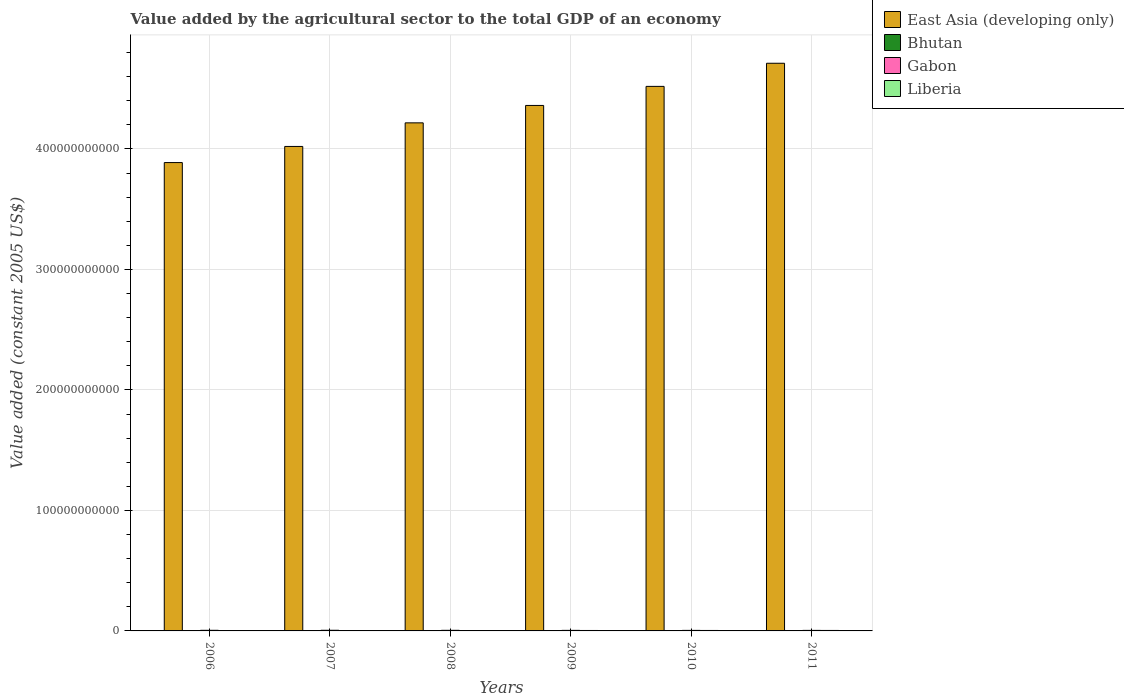Are the number of bars on each tick of the X-axis equal?
Provide a succinct answer. Yes. In how many cases, is the number of bars for a given year not equal to the number of legend labels?
Provide a succinct answer. 0. What is the value added by the agricultural sector in Liberia in 2008?
Make the answer very short. 3.48e+08. Across all years, what is the maximum value added by the agricultural sector in East Asia (developing only)?
Your response must be concise. 4.71e+11. Across all years, what is the minimum value added by the agricultural sector in Bhutan?
Make the answer very short. 1.88e+08. In which year was the value added by the agricultural sector in Liberia maximum?
Provide a short and direct response. 2011. In which year was the value added by the agricultural sector in Liberia minimum?
Your answer should be very brief. 2006. What is the total value added by the agricultural sector in Gabon in the graph?
Give a very brief answer. 2.90e+09. What is the difference between the value added by the agricultural sector in Bhutan in 2006 and that in 2010?
Offer a very short reply. -9.59e+06. What is the difference between the value added by the agricultural sector in Gabon in 2007 and the value added by the agricultural sector in Bhutan in 2006?
Give a very brief answer. 3.48e+08. What is the average value added by the agricultural sector in Gabon per year?
Offer a terse response. 4.83e+08. In the year 2008, what is the difference between the value added by the agricultural sector in Gabon and value added by the agricultural sector in Bhutan?
Give a very brief answer. 3.09e+08. In how many years, is the value added by the agricultural sector in Gabon greater than 120000000000 US$?
Ensure brevity in your answer.  0. What is the ratio of the value added by the agricultural sector in Bhutan in 2009 to that in 2010?
Provide a short and direct response. 0.99. Is the value added by the agricultural sector in Liberia in 2006 less than that in 2007?
Ensure brevity in your answer.  Yes. Is the difference between the value added by the agricultural sector in Gabon in 2007 and 2008 greater than the difference between the value added by the agricultural sector in Bhutan in 2007 and 2008?
Provide a succinct answer. Yes. What is the difference between the highest and the second highest value added by the agricultural sector in Liberia?
Your response must be concise. 1.48e+07. What is the difference between the highest and the lowest value added by the agricultural sector in East Asia (developing only)?
Provide a short and direct response. 8.24e+1. What does the 2nd bar from the left in 2011 represents?
Your response must be concise. Bhutan. What does the 2nd bar from the right in 2011 represents?
Your answer should be compact. Gabon. Is it the case that in every year, the sum of the value added by the agricultural sector in Liberia and value added by the agricultural sector in Bhutan is greater than the value added by the agricultural sector in Gabon?
Your answer should be compact. No. Are all the bars in the graph horizontal?
Provide a succinct answer. No. What is the difference between two consecutive major ticks on the Y-axis?
Offer a terse response. 1.00e+11. Are the values on the major ticks of Y-axis written in scientific E-notation?
Ensure brevity in your answer.  No. Does the graph contain any zero values?
Offer a very short reply. No. Does the graph contain grids?
Provide a short and direct response. Yes. How are the legend labels stacked?
Provide a short and direct response. Vertical. What is the title of the graph?
Keep it short and to the point. Value added by the agricultural sector to the total GDP of an economy. What is the label or title of the X-axis?
Make the answer very short. Years. What is the label or title of the Y-axis?
Give a very brief answer. Value added (constant 2005 US$). What is the Value added (constant 2005 US$) of East Asia (developing only) in 2006?
Keep it short and to the point. 3.89e+11. What is the Value added (constant 2005 US$) of Bhutan in 2006?
Your answer should be compact. 1.88e+08. What is the Value added (constant 2005 US$) of Gabon in 2006?
Offer a very short reply. 5.07e+08. What is the Value added (constant 2005 US$) of Liberia in 2006?
Ensure brevity in your answer.  2.93e+08. What is the Value added (constant 2005 US$) in East Asia (developing only) in 2007?
Give a very brief answer. 4.02e+11. What is the Value added (constant 2005 US$) in Bhutan in 2007?
Provide a short and direct response. 1.89e+08. What is the Value added (constant 2005 US$) in Gabon in 2007?
Provide a succinct answer. 5.36e+08. What is the Value added (constant 2005 US$) of Liberia in 2007?
Offer a very short reply. 3.15e+08. What is the Value added (constant 2005 US$) of East Asia (developing only) in 2008?
Provide a succinct answer. 4.22e+11. What is the Value added (constant 2005 US$) of Bhutan in 2008?
Your response must be concise. 1.90e+08. What is the Value added (constant 2005 US$) of Gabon in 2008?
Your response must be concise. 4.99e+08. What is the Value added (constant 2005 US$) of Liberia in 2008?
Offer a very short reply. 3.48e+08. What is the Value added (constant 2005 US$) in East Asia (developing only) in 2009?
Offer a terse response. 4.36e+11. What is the Value added (constant 2005 US$) in Bhutan in 2009?
Offer a very short reply. 1.95e+08. What is the Value added (constant 2005 US$) of Gabon in 2009?
Ensure brevity in your answer.  4.65e+08. What is the Value added (constant 2005 US$) in Liberia in 2009?
Keep it short and to the point. 3.66e+08. What is the Value added (constant 2005 US$) in East Asia (developing only) in 2010?
Your answer should be very brief. 4.52e+11. What is the Value added (constant 2005 US$) in Bhutan in 2010?
Provide a short and direct response. 1.97e+08. What is the Value added (constant 2005 US$) in Gabon in 2010?
Keep it short and to the point. 4.40e+08. What is the Value added (constant 2005 US$) of Liberia in 2010?
Provide a succinct answer. 3.79e+08. What is the Value added (constant 2005 US$) of East Asia (developing only) in 2011?
Keep it short and to the point. 4.71e+11. What is the Value added (constant 2005 US$) in Bhutan in 2011?
Offer a terse response. 2.02e+08. What is the Value added (constant 2005 US$) in Gabon in 2011?
Your answer should be very brief. 4.50e+08. What is the Value added (constant 2005 US$) of Liberia in 2011?
Your answer should be very brief. 3.94e+08. Across all years, what is the maximum Value added (constant 2005 US$) of East Asia (developing only)?
Offer a terse response. 4.71e+11. Across all years, what is the maximum Value added (constant 2005 US$) of Bhutan?
Provide a short and direct response. 2.02e+08. Across all years, what is the maximum Value added (constant 2005 US$) of Gabon?
Offer a terse response. 5.36e+08. Across all years, what is the maximum Value added (constant 2005 US$) of Liberia?
Offer a very short reply. 3.94e+08. Across all years, what is the minimum Value added (constant 2005 US$) in East Asia (developing only)?
Make the answer very short. 3.89e+11. Across all years, what is the minimum Value added (constant 2005 US$) in Bhutan?
Your response must be concise. 1.88e+08. Across all years, what is the minimum Value added (constant 2005 US$) of Gabon?
Ensure brevity in your answer.  4.40e+08. Across all years, what is the minimum Value added (constant 2005 US$) of Liberia?
Provide a succinct answer. 2.93e+08. What is the total Value added (constant 2005 US$) in East Asia (developing only) in the graph?
Your answer should be compact. 2.57e+12. What is the total Value added (constant 2005 US$) in Bhutan in the graph?
Ensure brevity in your answer.  1.16e+09. What is the total Value added (constant 2005 US$) in Gabon in the graph?
Your answer should be very brief. 2.90e+09. What is the total Value added (constant 2005 US$) in Liberia in the graph?
Your answer should be very brief. 2.10e+09. What is the difference between the Value added (constant 2005 US$) of East Asia (developing only) in 2006 and that in 2007?
Your answer should be very brief. -1.34e+1. What is the difference between the Value added (constant 2005 US$) in Bhutan in 2006 and that in 2007?
Your answer should be compact. -1.52e+06. What is the difference between the Value added (constant 2005 US$) in Gabon in 2006 and that in 2007?
Your response must be concise. -2.83e+07. What is the difference between the Value added (constant 2005 US$) of Liberia in 2006 and that in 2007?
Keep it short and to the point. -2.14e+07. What is the difference between the Value added (constant 2005 US$) of East Asia (developing only) in 2006 and that in 2008?
Ensure brevity in your answer.  -3.30e+1. What is the difference between the Value added (constant 2005 US$) in Bhutan in 2006 and that in 2008?
Offer a terse response. -2.86e+06. What is the difference between the Value added (constant 2005 US$) of Gabon in 2006 and that in 2008?
Provide a short and direct response. 8.09e+06. What is the difference between the Value added (constant 2005 US$) in Liberia in 2006 and that in 2008?
Your answer should be very brief. -5.45e+07. What is the difference between the Value added (constant 2005 US$) in East Asia (developing only) in 2006 and that in 2009?
Offer a very short reply. -4.74e+1. What is the difference between the Value added (constant 2005 US$) in Bhutan in 2006 and that in 2009?
Offer a terse response. -7.92e+06. What is the difference between the Value added (constant 2005 US$) in Gabon in 2006 and that in 2009?
Make the answer very short. 4.26e+07. What is the difference between the Value added (constant 2005 US$) of Liberia in 2006 and that in 2009?
Offer a terse response. -7.29e+07. What is the difference between the Value added (constant 2005 US$) in East Asia (developing only) in 2006 and that in 2010?
Make the answer very short. -6.32e+1. What is the difference between the Value added (constant 2005 US$) in Bhutan in 2006 and that in 2010?
Make the answer very short. -9.59e+06. What is the difference between the Value added (constant 2005 US$) in Gabon in 2006 and that in 2010?
Keep it short and to the point. 6.69e+07. What is the difference between the Value added (constant 2005 US$) of Liberia in 2006 and that in 2010?
Offer a very short reply. -8.61e+07. What is the difference between the Value added (constant 2005 US$) of East Asia (developing only) in 2006 and that in 2011?
Offer a very short reply. -8.24e+1. What is the difference between the Value added (constant 2005 US$) in Bhutan in 2006 and that in 2011?
Give a very brief answer. -1.43e+07. What is the difference between the Value added (constant 2005 US$) of Gabon in 2006 and that in 2011?
Provide a short and direct response. 5.69e+07. What is the difference between the Value added (constant 2005 US$) in Liberia in 2006 and that in 2011?
Keep it short and to the point. -1.01e+08. What is the difference between the Value added (constant 2005 US$) of East Asia (developing only) in 2007 and that in 2008?
Provide a succinct answer. -1.96e+1. What is the difference between the Value added (constant 2005 US$) of Bhutan in 2007 and that in 2008?
Give a very brief answer. -1.34e+06. What is the difference between the Value added (constant 2005 US$) in Gabon in 2007 and that in 2008?
Offer a terse response. 3.63e+07. What is the difference between the Value added (constant 2005 US$) of Liberia in 2007 and that in 2008?
Your response must be concise. -3.32e+07. What is the difference between the Value added (constant 2005 US$) in East Asia (developing only) in 2007 and that in 2009?
Your answer should be compact. -3.40e+1. What is the difference between the Value added (constant 2005 US$) of Bhutan in 2007 and that in 2009?
Provide a succinct answer. -6.40e+06. What is the difference between the Value added (constant 2005 US$) of Gabon in 2007 and that in 2009?
Make the answer very short. 7.09e+07. What is the difference between the Value added (constant 2005 US$) of Liberia in 2007 and that in 2009?
Your answer should be compact. -5.15e+07. What is the difference between the Value added (constant 2005 US$) in East Asia (developing only) in 2007 and that in 2010?
Your answer should be compact. -4.99e+1. What is the difference between the Value added (constant 2005 US$) in Bhutan in 2007 and that in 2010?
Offer a very short reply. -8.07e+06. What is the difference between the Value added (constant 2005 US$) in Gabon in 2007 and that in 2010?
Your answer should be very brief. 9.51e+07. What is the difference between the Value added (constant 2005 US$) in Liberia in 2007 and that in 2010?
Offer a very short reply. -6.47e+07. What is the difference between the Value added (constant 2005 US$) in East Asia (developing only) in 2007 and that in 2011?
Your answer should be very brief. -6.91e+1. What is the difference between the Value added (constant 2005 US$) of Bhutan in 2007 and that in 2011?
Make the answer very short. -1.28e+07. What is the difference between the Value added (constant 2005 US$) of Gabon in 2007 and that in 2011?
Provide a succinct answer. 8.52e+07. What is the difference between the Value added (constant 2005 US$) of Liberia in 2007 and that in 2011?
Keep it short and to the point. -7.95e+07. What is the difference between the Value added (constant 2005 US$) in East Asia (developing only) in 2008 and that in 2009?
Give a very brief answer. -1.45e+1. What is the difference between the Value added (constant 2005 US$) of Bhutan in 2008 and that in 2009?
Ensure brevity in your answer.  -5.06e+06. What is the difference between the Value added (constant 2005 US$) in Gabon in 2008 and that in 2009?
Make the answer very short. 3.45e+07. What is the difference between the Value added (constant 2005 US$) of Liberia in 2008 and that in 2009?
Your answer should be compact. -1.83e+07. What is the difference between the Value added (constant 2005 US$) of East Asia (developing only) in 2008 and that in 2010?
Your answer should be very brief. -3.03e+1. What is the difference between the Value added (constant 2005 US$) in Bhutan in 2008 and that in 2010?
Provide a short and direct response. -6.73e+06. What is the difference between the Value added (constant 2005 US$) of Gabon in 2008 and that in 2010?
Offer a very short reply. 5.88e+07. What is the difference between the Value added (constant 2005 US$) of Liberia in 2008 and that in 2010?
Provide a succinct answer. -3.15e+07. What is the difference between the Value added (constant 2005 US$) in East Asia (developing only) in 2008 and that in 2011?
Ensure brevity in your answer.  -4.95e+1. What is the difference between the Value added (constant 2005 US$) of Bhutan in 2008 and that in 2011?
Ensure brevity in your answer.  -1.15e+07. What is the difference between the Value added (constant 2005 US$) of Gabon in 2008 and that in 2011?
Your answer should be compact. 4.89e+07. What is the difference between the Value added (constant 2005 US$) of Liberia in 2008 and that in 2011?
Make the answer very short. -4.63e+07. What is the difference between the Value added (constant 2005 US$) in East Asia (developing only) in 2009 and that in 2010?
Offer a very short reply. -1.58e+1. What is the difference between the Value added (constant 2005 US$) in Bhutan in 2009 and that in 2010?
Make the answer very short. -1.67e+06. What is the difference between the Value added (constant 2005 US$) in Gabon in 2009 and that in 2010?
Your answer should be compact. 2.42e+07. What is the difference between the Value added (constant 2005 US$) in Liberia in 2009 and that in 2010?
Provide a succinct answer. -1.32e+07. What is the difference between the Value added (constant 2005 US$) in East Asia (developing only) in 2009 and that in 2011?
Provide a succinct answer. -3.50e+1. What is the difference between the Value added (constant 2005 US$) of Bhutan in 2009 and that in 2011?
Keep it short and to the point. -6.42e+06. What is the difference between the Value added (constant 2005 US$) in Gabon in 2009 and that in 2011?
Provide a succinct answer. 1.43e+07. What is the difference between the Value added (constant 2005 US$) of Liberia in 2009 and that in 2011?
Your answer should be very brief. -2.79e+07. What is the difference between the Value added (constant 2005 US$) of East Asia (developing only) in 2010 and that in 2011?
Ensure brevity in your answer.  -1.92e+1. What is the difference between the Value added (constant 2005 US$) of Bhutan in 2010 and that in 2011?
Offer a terse response. -4.76e+06. What is the difference between the Value added (constant 2005 US$) in Gabon in 2010 and that in 2011?
Offer a terse response. -9.92e+06. What is the difference between the Value added (constant 2005 US$) in Liberia in 2010 and that in 2011?
Offer a very short reply. -1.48e+07. What is the difference between the Value added (constant 2005 US$) of East Asia (developing only) in 2006 and the Value added (constant 2005 US$) of Bhutan in 2007?
Give a very brief answer. 3.89e+11. What is the difference between the Value added (constant 2005 US$) in East Asia (developing only) in 2006 and the Value added (constant 2005 US$) in Gabon in 2007?
Make the answer very short. 3.88e+11. What is the difference between the Value added (constant 2005 US$) of East Asia (developing only) in 2006 and the Value added (constant 2005 US$) of Liberia in 2007?
Ensure brevity in your answer.  3.88e+11. What is the difference between the Value added (constant 2005 US$) of Bhutan in 2006 and the Value added (constant 2005 US$) of Gabon in 2007?
Offer a very short reply. -3.48e+08. What is the difference between the Value added (constant 2005 US$) of Bhutan in 2006 and the Value added (constant 2005 US$) of Liberia in 2007?
Give a very brief answer. -1.27e+08. What is the difference between the Value added (constant 2005 US$) in Gabon in 2006 and the Value added (constant 2005 US$) in Liberia in 2007?
Give a very brief answer. 1.93e+08. What is the difference between the Value added (constant 2005 US$) in East Asia (developing only) in 2006 and the Value added (constant 2005 US$) in Bhutan in 2008?
Keep it short and to the point. 3.89e+11. What is the difference between the Value added (constant 2005 US$) in East Asia (developing only) in 2006 and the Value added (constant 2005 US$) in Gabon in 2008?
Your answer should be very brief. 3.88e+11. What is the difference between the Value added (constant 2005 US$) of East Asia (developing only) in 2006 and the Value added (constant 2005 US$) of Liberia in 2008?
Offer a very short reply. 3.88e+11. What is the difference between the Value added (constant 2005 US$) of Bhutan in 2006 and the Value added (constant 2005 US$) of Gabon in 2008?
Provide a short and direct response. -3.12e+08. What is the difference between the Value added (constant 2005 US$) in Bhutan in 2006 and the Value added (constant 2005 US$) in Liberia in 2008?
Your answer should be compact. -1.60e+08. What is the difference between the Value added (constant 2005 US$) of Gabon in 2006 and the Value added (constant 2005 US$) of Liberia in 2008?
Offer a very short reply. 1.59e+08. What is the difference between the Value added (constant 2005 US$) in East Asia (developing only) in 2006 and the Value added (constant 2005 US$) in Bhutan in 2009?
Your response must be concise. 3.89e+11. What is the difference between the Value added (constant 2005 US$) in East Asia (developing only) in 2006 and the Value added (constant 2005 US$) in Gabon in 2009?
Offer a very short reply. 3.88e+11. What is the difference between the Value added (constant 2005 US$) in East Asia (developing only) in 2006 and the Value added (constant 2005 US$) in Liberia in 2009?
Keep it short and to the point. 3.88e+11. What is the difference between the Value added (constant 2005 US$) of Bhutan in 2006 and the Value added (constant 2005 US$) of Gabon in 2009?
Provide a succinct answer. -2.77e+08. What is the difference between the Value added (constant 2005 US$) in Bhutan in 2006 and the Value added (constant 2005 US$) in Liberia in 2009?
Give a very brief answer. -1.79e+08. What is the difference between the Value added (constant 2005 US$) in Gabon in 2006 and the Value added (constant 2005 US$) in Liberia in 2009?
Your answer should be compact. 1.41e+08. What is the difference between the Value added (constant 2005 US$) in East Asia (developing only) in 2006 and the Value added (constant 2005 US$) in Bhutan in 2010?
Keep it short and to the point. 3.89e+11. What is the difference between the Value added (constant 2005 US$) in East Asia (developing only) in 2006 and the Value added (constant 2005 US$) in Gabon in 2010?
Your response must be concise. 3.88e+11. What is the difference between the Value added (constant 2005 US$) in East Asia (developing only) in 2006 and the Value added (constant 2005 US$) in Liberia in 2010?
Offer a terse response. 3.88e+11. What is the difference between the Value added (constant 2005 US$) in Bhutan in 2006 and the Value added (constant 2005 US$) in Gabon in 2010?
Offer a very short reply. -2.53e+08. What is the difference between the Value added (constant 2005 US$) of Bhutan in 2006 and the Value added (constant 2005 US$) of Liberia in 2010?
Give a very brief answer. -1.92e+08. What is the difference between the Value added (constant 2005 US$) in Gabon in 2006 and the Value added (constant 2005 US$) in Liberia in 2010?
Give a very brief answer. 1.28e+08. What is the difference between the Value added (constant 2005 US$) of East Asia (developing only) in 2006 and the Value added (constant 2005 US$) of Bhutan in 2011?
Provide a succinct answer. 3.89e+11. What is the difference between the Value added (constant 2005 US$) of East Asia (developing only) in 2006 and the Value added (constant 2005 US$) of Gabon in 2011?
Ensure brevity in your answer.  3.88e+11. What is the difference between the Value added (constant 2005 US$) of East Asia (developing only) in 2006 and the Value added (constant 2005 US$) of Liberia in 2011?
Make the answer very short. 3.88e+11. What is the difference between the Value added (constant 2005 US$) in Bhutan in 2006 and the Value added (constant 2005 US$) in Gabon in 2011?
Offer a terse response. -2.63e+08. What is the difference between the Value added (constant 2005 US$) of Bhutan in 2006 and the Value added (constant 2005 US$) of Liberia in 2011?
Provide a succinct answer. -2.07e+08. What is the difference between the Value added (constant 2005 US$) in Gabon in 2006 and the Value added (constant 2005 US$) in Liberia in 2011?
Offer a very short reply. 1.13e+08. What is the difference between the Value added (constant 2005 US$) of East Asia (developing only) in 2007 and the Value added (constant 2005 US$) of Bhutan in 2008?
Provide a short and direct response. 4.02e+11. What is the difference between the Value added (constant 2005 US$) in East Asia (developing only) in 2007 and the Value added (constant 2005 US$) in Gabon in 2008?
Your answer should be compact. 4.02e+11. What is the difference between the Value added (constant 2005 US$) of East Asia (developing only) in 2007 and the Value added (constant 2005 US$) of Liberia in 2008?
Provide a short and direct response. 4.02e+11. What is the difference between the Value added (constant 2005 US$) in Bhutan in 2007 and the Value added (constant 2005 US$) in Gabon in 2008?
Your answer should be very brief. -3.10e+08. What is the difference between the Value added (constant 2005 US$) of Bhutan in 2007 and the Value added (constant 2005 US$) of Liberia in 2008?
Offer a terse response. -1.59e+08. What is the difference between the Value added (constant 2005 US$) of Gabon in 2007 and the Value added (constant 2005 US$) of Liberia in 2008?
Provide a succinct answer. 1.88e+08. What is the difference between the Value added (constant 2005 US$) in East Asia (developing only) in 2007 and the Value added (constant 2005 US$) in Bhutan in 2009?
Give a very brief answer. 4.02e+11. What is the difference between the Value added (constant 2005 US$) of East Asia (developing only) in 2007 and the Value added (constant 2005 US$) of Gabon in 2009?
Provide a succinct answer. 4.02e+11. What is the difference between the Value added (constant 2005 US$) of East Asia (developing only) in 2007 and the Value added (constant 2005 US$) of Liberia in 2009?
Your response must be concise. 4.02e+11. What is the difference between the Value added (constant 2005 US$) in Bhutan in 2007 and the Value added (constant 2005 US$) in Gabon in 2009?
Your response must be concise. -2.76e+08. What is the difference between the Value added (constant 2005 US$) of Bhutan in 2007 and the Value added (constant 2005 US$) of Liberia in 2009?
Give a very brief answer. -1.77e+08. What is the difference between the Value added (constant 2005 US$) in Gabon in 2007 and the Value added (constant 2005 US$) in Liberia in 2009?
Provide a succinct answer. 1.69e+08. What is the difference between the Value added (constant 2005 US$) of East Asia (developing only) in 2007 and the Value added (constant 2005 US$) of Bhutan in 2010?
Give a very brief answer. 4.02e+11. What is the difference between the Value added (constant 2005 US$) of East Asia (developing only) in 2007 and the Value added (constant 2005 US$) of Gabon in 2010?
Keep it short and to the point. 4.02e+11. What is the difference between the Value added (constant 2005 US$) in East Asia (developing only) in 2007 and the Value added (constant 2005 US$) in Liberia in 2010?
Provide a succinct answer. 4.02e+11. What is the difference between the Value added (constant 2005 US$) in Bhutan in 2007 and the Value added (constant 2005 US$) in Gabon in 2010?
Your response must be concise. -2.51e+08. What is the difference between the Value added (constant 2005 US$) in Bhutan in 2007 and the Value added (constant 2005 US$) in Liberia in 2010?
Make the answer very short. -1.90e+08. What is the difference between the Value added (constant 2005 US$) of Gabon in 2007 and the Value added (constant 2005 US$) of Liberia in 2010?
Keep it short and to the point. 1.56e+08. What is the difference between the Value added (constant 2005 US$) of East Asia (developing only) in 2007 and the Value added (constant 2005 US$) of Bhutan in 2011?
Provide a short and direct response. 4.02e+11. What is the difference between the Value added (constant 2005 US$) in East Asia (developing only) in 2007 and the Value added (constant 2005 US$) in Gabon in 2011?
Ensure brevity in your answer.  4.02e+11. What is the difference between the Value added (constant 2005 US$) of East Asia (developing only) in 2007 and the Value added (constant 2005 US$) of Liberia in 2011?
Your answer should be very brief. 4.02e+11. What is the difference between the Value added (constant 2005 US$) of Bhutan in 2007 and the Value added (constant 2005 US$) of Gabon in 2011?
Keep it short and to the point. -2.61e+08. What is the difference between the Value added (constant 2005 US$) of Bhutan in 2007 and the Value added (constant 2005 US$) of Liberia in 2011?
Ensure brevity in your answer.  -2.05e+08. What is the difference between the Value added (constant 2005 US$) in Gabon in 2007 and the Value added (constant 2005 US$) in Liberia in 2011?
Offer a very short reply. 1.41e+08. What is the difference between the Value added (constant 2005 US$) of East Asia (developing only) in 2008 and the Value added (constant 2005 US$) of Bhutan in 2009?
Make the answer very short. 4.22e+11. What is the difference between the Value added (constant 2005 US$) in East Asia (developing only) in 2008 and the Value added (constant 2005 US$) in Gabon in 2009?
Keep it short and to the point. 4.21e+11. What is the difference between the Value added (constant 2005 US$) in East Asia (developing only) in 2008 and the Value added (constant 2005 US$) in Liberia in 2009?
Make the answer very short. 4.21e+11. What is the difference between the Value added (constant 2005 US$) of Bhutan in 2008 and the Value added (constant 2005 US$) of Gabon in 2009?
Offer a terse response. -2.74e+08. What is the difference between the Value added (constant 2005 US$) in Bhutan in 2008 and the Value added (constant 2005 US$) in Liberia in 2009?
Provide a short and direct response. -1.76e+08. What is the difference between the Value added (constant 2005 US$) in Gabon in 2008 and the Value added (constant 2005 US$) in Liberia in 2009?
Give a very brief answer. 1.33e+08. What is the difference between the Value added (constant 2005 US$) in East Asia (developing only) in 2008 and the Value added (constant 2005 US$) in Bhutan in 2010?
Make the answer very short. 4.21e+11. What is the difference between the Value added (constant 2005 US$) of East Asia (developing only) in 2008 and the Value added (constant 2005 US$) of Gabon in 2010?
Make the answer very short. 4.21e+11. What is the difference between the Value added (constant 2005 US$) of East Asia (developing only) in 2008 and the Value added (constant 2005 US$) of Liberia in 2010?
Ensure brevity in your answer.  4.21e+11. What is the difference between the Value added (constant 2005 US$) in Bhutan in 2008 and the Value added (constant 2005 US$) in Gabon in 2010?
Keep it short and to the point. -2.50e+08. What is the difference between the Value added (constant 2005 US$) of Bhutan in 2008 and the Value added (constant 2005 US$) of Liberia in 2010?
Make the answer very short. -1.89e+08. What is the difference between the Value added (constant 2005 US$) of Gabon in 2008 and the Value added (constant 2005 US$) of Liberia in 2010?
Offer a terse response. 1.20e+08. What is the difference between the Value added (constant 2005 US$) in East Asia (developing only) in 2008 and the Value added (constant 2005 US$) in Bhutan in 2011?
Offer a very short reply. 4.21e+11. What is the difference between the Value added (constant 2005 US$) in East Asia (developing only) in 2008 and the Value added (constant 2005 US$) in Gabon in 2011?
Provide a short and direct response. 4.21e+11. What is the difference between the Value added (constant 2005 US$) of East Asia (developing only) in 2008 and the Value added (constant 2005 US$) of Liberia in 2011?
Offer a very short reply. 4.21e+11. What is the difference between the Value added (constant 2005 US$) in Bhutan in 2008 and the Value added (constant 2005 US$) in Gabon in 2011?
Provide a short and direct response. -2.60e+08. What is the difference between the Value added (constant 2005 US$) in Bhutan in 2008 and the Value added (constant 2005 US$) in Liberia in 2011?
Offer a very short reply. -2.04e+08. What is the difference between the Value added (constant 2005 US$) of Gabon in 2008 and the Value added (constant 2005 US$) of Liberia in 2011?
Offer a terse response. 1.05e+08. What is the difference between the Value added (constant 2005 US$) in East Asia (developing only) in 2009 and the Value added (constant 2005 US$) in Bhutan in 2010?
Your answer should be very brief. 4.36e+11. What is the difference between the Value added (constant 2005 US$) of East Asia (developing only) in 2009 and the Value added (constant 2005 US$) of Gabon in 2010?
Your answer should be compact. 4.36e+11. What is the difference between the Value added (constant 2005 US$) of East Asia (developing only) in 2009 and the Value added (constant 2005 US$) of Liberia in 2010?
Provide a short and direct response. 4.36e+11. What is the difference between the Value added (constant 2005 US$) of Bhutan in 2009 and the Value added (constant 2005 US$) of Gabon in 2010?
Your answer should be very brief. -2.45e+08. What is the difference between the Value added (constant 2005 US$) in Bhutan in 2009 and the Value added (constant 2005 US$) in Liberia in 2010?
Your answer should be compact. -1.84e+08. What is the difference between the Value added (constant 2005 US$) in Gabon in 2009 and the Value added (constant 2005 US$) in Liberia in 2010?
Provide a succinct answer. 8.53e+07. What is the difference between the Value added (constant 2005 US$) in East Asia (developing only) in 2009 and the Value added (constant 2005 US$) in Bhutan in 2011?
Ensure brevity in your answer.  4.36e+11. What is the difference between the Value added (constant 2005 US$) in East Asia (developing only) in 2009 and the Value added (constant 2005 US$) in Gabon in 2011?
Offer a terse response. 4.36e+11. What is the difference between the Value added (constant 2005 US$) of East Asia (developing only) in 2009 and the Value added (constant 2005 US$) of Liberia in 2011?
Offer a terse response. 4.36e+11. What is the difference between the Value added (constant 2005 US$) in Bhutan in 2009 and the Value added (constant 2005 US$) in Gabon in 2011?
Ensure brevity in your answer.  -2.55e+08. What is the difference between the Value added (constant 2005 US$) in Bhutan in 2009 and the Value added (constant 2005 US$) in Liberia in 2011?
Provide a short and direct response. -1.99e+08. What is the difference between the Value added (constant 2005 US$) in Gabon in 2009 and the Value added (constant 2005 US$) in Liberia in 2011?
Keep it short and to the point. 7.05e+07. What is the difference between the Value added (constant 2005 US$) of East Asia (developing only) in 2010 and the Value added (constant 2005 US$) of Bhutan in 2011?
Your answer should be compact. 4.52e+11. What is the difference between the Value added (constant 2005 US$) in East Asia (developing only) in 2010 and the Value added (constant 2005 US$) in Gabon in 2011?
Provide a succinct answer. 4.52e+11. What is the difference between the Value added (constant 2005 US$) of East Asia (developing only) in 2010 and the Value added (constant 2005 US$) of Liberia in 2011?
Ensure brevity in your answer.  4.52e+11. What is the difference between the Value added (constant 2005 US$) in Bhutan in 2010 and the Value added (constant 2005 US$) in Gabon in 2011?
Keep it short and to the point. -2.53e+08. What is the difference between the Value added (constant 2005 US$) of Bhutan in 2010 and the Value added (constant 2005 US$) of Liberia in 2011?
Your response must be concise. -1.97e+08. What is the difference between the Value added (constant 2005 US$) of Gabon in 2010 and the Value added (constant 2005 US$) of Liberia in 2011?
Your response must be concise. 4.63e+07. What is the average Value added (constant 2005 US$) in East Asia (developing only) per year?
Make the answer very short. 4.29e+11. What is the average Value added (constant 2005 US$) in Bhutan per year?
Provide a succinct answer. 1.94e+08. What is the average Value added (constant 2005 US$) of Gabon per year?
Your response must be concise. 4.83e+08. What is the average Value added (constant 2005 US$) of Liberia per year?
Ensure brevity in your answer.  3.49e+08. In the year 2006, what is the difference between the Value added (constant 2005 US$) in East Asia (developing only) and Value added (constant 2005 US$) in Bhutan?
Make the answer very short. 3.89e+11. In the year 2006, what is the difference between the Value added (constant 2005 US$) in East Asia (developing only) and Value added (constant 2005 US$) in Gabon?
Offer a terse response. 3.88e+11. In the year 2006, what is the difference between the Value added (constant 2005 US$) in East Asia (developing only) and Value added (constant 2005 US$) in Liberia?
Your answer should be very brief. 3.88e+11. In the year 2006, what is the difference between the Value added (constant 2005 US$) in Bhutan and Value added (constant 2005 US$) in Gabon?
Your response must be concise. -3.20e+08. In the year 2006, what is the difference between the Value added (constant 2005 US$) in Bhutan and Value added (constant 2005 US$) in Liberia?
Your response must be concise. -1.06e+08. In the year 2006, what is the difference between the Value added (constant 2005 US$) of Gabon and Value added (constant 2005 US$) of Liberia?
Offer a terse response. 2.14e+08. In the year 2007, what is the difference between the Value added (constant 2005 US$) in East Asia (developing only) and Value added (constant 2005 US$) in Bhutan?
Offer a very short reply. 4.02e+11. In the year 2007, what is the difference between the Value added (constant 2005 US$) in East Asia (developing only) and Value added (constant 2005 US$) in Gabon?
Offer a very short reply. 4.02e+11. In the year 2007, what is the difference between the Value added (constant 2005 US$) of East Asia (developing only) and Value added (constant 2005 US$) of Liberia?
Keep it short and to the point. 4.02e+11. In the year 2007, what is the difference between the Value added (constant 2005 US$) in Bhutan and Value added (constant 2005 US$) in Gabon?
Offer a very short reply. -3.47e+08. In the year 2007, what is the difference between the Value added (constant 2005 US$) of Bhutan and Value added (constant 2005 US$) of Liberia?
Provide a succinct answer. -1.26e+08. In the year 2007, what is the difference between the Value added (constant 2005 US$) of Gabon and Value added (constant 2005 US$) of Liberia?
Offer a very short reply. 2.21e+08. In the year 2008, what is the difference between the Value added (constant 2005 US$) of East Asia (developing only) and Value added (constant 2005 US$) of Bhutan?
Make the answer very short. 4.22e+11. In the year 2008, what is the difference between the Value added (constant 2005 US$) of East Asia (developing only) and Value added (constant 2005 US$) of Gabon?
Give a very brief answer. 4.21e+11. In the year 2008, what is the difference between the Value added (constant 2005 US$) in East Asia (developing only) and Value added (constant 2005 US$) in Liberia?
Offer a terse response. 4.21e+11. In the year 2008, what is the difference between the Value added (constant 2005 US$) of Bhutan and Value added (constant 2005 US$) of Gabon?
Keep it short and to the point. -3.09e+08. In the year 2008, what is the difference between the Value added (constant 2005 US$) of Bhutan and Value added (constant 2005 US$) of Liberia?
Provide a short and direct response. -1.58e+08. In the year 2008, what is the difference between the Value added (constant 2005 US$) in Gabon and Value added (constant 2005 US$) in Liberia?
Your answer should be very brief. 1.51e+08. In the year 2009, what is the difference between the Value added (constant 2005 US$) in East Asia (developing only) and Value added (constant 2005 US$) in Bhutan?
Your response must be concise. 4.36e+11. In the year 2009, what is the difference between the Value added (constant 2005 US$) of East Asia (developing only) and Value added (constant 2005 US$) of Gabon?
Provide a succinct answer. 4.36e+11. In the year 2009, what is the difference between the Value added (constant 2005 US$) in East Asia (developing only) and Value added (constant 2005 US$) in Liberia?
Give a very brief answer. 4.36e+11. In the year 2009, what is the difference between the Value added (constant 2005 US$) of Bhutan and Value added (constant 2005 US$) of Gabon?
Provide a short and direct response. -2.69e+08. In the year 2009, what is the difference between the Value added (constant 2005 US$) of Bhutan and Value added (constant 2005 US$) of Liberia?
Keep it short and to the point. -1.71e+08. In the year 2009, what is the difference between the Value added (constant 2005 US$) of Gabon and Value added (constant 2005 US$) of Liberia?
Ensure brevity in your answer.  9.85e+07. In the year 2010, what is the difference between the Value added (constant 2005 US$) in East Asia (developing only) and Value added (constant 2005 US$) in Bhutan?
Keep it short and to the point. 4.52e+11. In the year 2010, what is the difference between the Value added (constant 2005 US$) of East Asia (developing only) and Value added (constant 2005 US$) of Gabon?
Your answer should be very brief. 4.52e+11. In the year 2010, what is the difference between the Value added (constant 2005 US$) of East Asia (developing only) and Value added (constant 2005 US$) of Liberia?
Your answer should be very brief. 4.52e+11. In the year 2010, what is the difference between the Value added (constant 2005 US$) in Bhutan and Value added (constant 2005 US$) in Gabon?
Make the answer very short. -2.43e+08. In the year 2010, what is the difference between the Value added (constant 2005 US$) in Bhutan and Value added (constant 2005 US$) in Liberia?
Keep it short and to the point. -1.82e+08. In the year 2010, what is the difference between the Value added (constant 2005 US$) in Gabon and Value added (constant 2005 US$) in Liberia?
Make the answer very short. 6.11e+07. In the year 2011, what is the difference between the Value added (constant 2005 US$) of East Asia (developing only) and Value added (constant 2005 US$) of Bhutan?
Provide a succinct answer. 4.71e+11. In the year 2011, what is the difference between the Value added (constant 2005 US$) of East Asia (developing only) and Value added (constant 2005 US$) of Gabon?
Give a very brief answer. 4.71e+11. In the year 2011, what is the difference between the Value added (constant 2005 US$) of East Asia (developing only) and Value added (constant 2005 US$) of Liberia?
Provide a short and direct response. 4.71e+11. In the year 2011, what is the difference between the Value added (constant 2005 US$) of Bhutan and Value added (constant 2005 US$) of Gabon?
Make the answer very short. -2.49e+08. In the year 2011, what is the difference between the Value added (constant 2005 US$) of Bhutan and Value added (constant 2005 US$) of Liberia?
Ensure brevity in your answer.  -1.92e+08. In the year 2011, what is the difference between the Value added (constant 2005 US$) in Gabon and Value added (constant 2005 US$) in Liberia?
Your answer should be very brief. 5.62e+07. What is the ratio of the Value added (constant 2005 US$) of East Asia (developing only) in 2006 to that in 2007?
Provide a short and direct response. 0.97. What is the ratio of the Value added (constant 2005 US$) in Gabon in 2006 to that in 2007?
Your response must be concise. 0.95. What is the ratio of the Value added (constant 2005 US$) of Liberia in 2006 to that in 2007?
Your response must be concise. 0.93. What is the ratio of the Value added (constant 2005 US$) of East Asia (developing only) in 2006 to that in 2008?
Keep it short and to the point. 0.92. What is the ratio of the Value added (constant 2005 US$) in Bhutan in 2006 to that in 2008?
Offer a very short reply. 0.98. What is the ratio of the Value added (constant 2005 US$) of Gabon in 2006 to that in 2008?
Give a very brief answer. 1.02. What is the ratio of the Value added (constant 2005 US$) of Liberia in 2006 to that in 2008?
Provide a succinct answer. 0.84. What is the ratio of the Value added (constant 2005 US$) in East Asia (developing only) in 2006 to that in 2009?
Provide a short and direct response. 0.89. What is the ratio of the Value added (constant 2005 US$) of Bhutan in 2006 to that in 2009?
Offer a terse response. 0.96. What is the ratio of the Value added (constant 2005 US$) in Gabon in 2006 to that in 2009?
Make the answer very short. 1.09. What is the ratio of the Value added (constant 2005 US$) of Liberia in 2006 to that in 2009?
Your response must be concise. 0.8. What is the ratio of the Value added (constant 2005 US$) of East Asia (developing only) in 2006 to that in 2010?
Your answer should be very brief. 0.86. What is the ratio of the Value added (constant 2005 US$) in Bhutan in 2006 to that in 2010?
Provide a succinct answer. 0.95. What is the ratio of the Value added (constant 2005 US$) in Gabon in 2006 to that in 2010?
Your response must be concise. 1.15. What is the ratio of the Value added (constant 2005 US$) of Liberia in 2006 to that in 2010?
Your answer should be very brief. 0.77. What is the ratio of the Value added (constant 2005 US$) of East Asia (developing only) in 2006 to that in 2011?
Your response must be concise. 0.82. What is the ratio of the Value added (constant 2005 US$) in Bhutan in 2006 to that in 2011?
Make the answer very short. 0.93. What is the ratio of the Value added (constant 2005 US$) in Gabon in 2006 to that in 2011?
Make the answer very short. 1.13. What is the ratio of the Value added (constant 2005 US$) in Liberia in 2006 to that in 2011?
Your answer should be very brief. 0.74. What is the ratio of the Value added (constant 2005 US$) in East Asia (developing only) in 2007 to that in 2008?
Offer a terse response. 0.95. What is the ratio of the Value added (constant 2005 US$) in Gabon in 2007 to that in 2008?
Offer a very short reply. 1.07. What is the ratio of the Value added (constant 2005 US$) in Liberia in 2007 to that in 2008?
Your response must be concise. 0.9. What is the ratio of the Value added (constant 2005 US$) of East Asia (developing only) in 2007 to that in 2009?
Ensure brevity in your answer.  0.92. What is the ratio of the Value added (constant 2005 US$) of Bhutan in 2007 to that in 2009?
Give a very brief answer. 0.97. What is the ratio of the Value added (constant 2005 US$) of Gabon in 2007 to that in 2009?
Provide a succinct answer. 1.15. What is the ratio of the Value added (constant 2005 US$) in Liberia in 2007 to that in 2009?
Provide a short and direct response. 0.86. What is the ratio of the Value added (constant 2005 US$) of East Asia (developing only) in 2007 to that in 2010?
Your answer should be compact. 0.89. What is the ratio of the Value added (constant 2005 US$) in Bhutan in 2007 to that in 2010?
Your answer should be very brief. 0.96. What is the ratio of the Value added (constant 2005 US$) in Gabon in 2007 to that in 2010?
Make the answer very short. 1.22. What is the ratio of the Value added (constant 2005 US$) of Liberia in 2007 to that in 2010?
Offer a terse response. 0.83. What is the ratio of the Value added (constant 2005 US$) of East Asia (developing only) in 2007 to that in 2011?
Offer a terse response. 0.85. What is the ratio of the Value added (constant 2005 US$) in Bhutan in 2007 to that in 2011?
Give a very brief answer. 0.94. What is the ratio of the Value added (constant 2005 US$) in Gabon in 2007 to that in 2011?
Provide a succinct answer. 1.19. What is the ratio of the Value added (constant 2005 US$) in Liberia in 2007 to that in 2011?
Keep it short and to the point. 0.8. What is the ratio of the Value added (constant 2005 US$) in East Asia (developing only) in 2008 to that in 2009?
Give a very brief answer. 0.97. What is the ratio of the Value added (constant 2005 US$) in Bhutan in 2008 to that in 2009?
Make the answer very short. 0.97. What is the ratio of the Value added (constant 2005 US$) of Gabon in 2008 to that in 2009?
Keep it short and to the point. 1.07. What is the ratio of the Value added (constant 2005 US$) in Liberia in 2008 to that in 2009?
Offer a terse response. 0.95. What is the ratio of the Value added (constant 2005 US$) of East Asia (developing only) in 2008 to that in 2010?
Make the answer very short. 0.93. What is the ratio of the Value added (constant 2005 US$) of Bhutan in 2008 to that in 2010?
Provide a short and direct response. 0.97. What is the ratio of the Value added (constant 2005 US$) of Gabon in 2008 to that in 2010?
Make the answer very short. 1.13. What is the ratio of the Value added (constant 2005 US$) of Liberia in 2008 to that in 2010?
Your answer should be compact. 0.92. What is the ratio of the Value added (constant 2005 US$) in East Asia (developing only) in 2008 to that in 2011?
Your answer should be compact. 0.9. What is the ratio of the Value added (constant 2005 US$) of Bhutan in 2008 to that in 2011?
Ensure brevity in your answer.  0.94. What is the ratio of the Value added (constant 2005 US$) of Gabon in 2008 to that in 2011?
Your answer should be very brief. 1.11. What is the ratio of the Value added (constant 2005 US$) in Liberia in 2008 to that in 2011?
Make the answer very short. 0.88. What is the ratio of the Value added (constant 2005 US$) in Bhutan in 2009 to that in 2010?
Give a very brief answer. 0.99. What is the ratio of the Value added (constant 2005 US$) in Gabon in 2009 to that in 2010?
Offer a very short reply. 1.05. What is the ratio of the Value added (constant 2005 US$) of Liberia in 2009 to that in 2010?
Offer a terse response. 0.97. What is the ratio of the Value added (constant 2005 US$) in East Asia (developing only) in 2009 to that in 2011?
Offer a terse response. 0.93. What is the ratio of the Value added (constant 2005 US$) in Bhutan in 2009 to that in 2011?
Provide a short and direct response. 0.97. What is the ratio of the Value added (constant 2005 US$) in Gabon in 2009 to that in 2011?
Keep it short and to the point. 1.03. What is the ratio of the Value added (constant 2005 US$) in Liberia in 2009 to that in 2011?
Ensure brevity in your answer.  0.93. What is the ratio of the Value added (constant 2005 US$) in East Asia (developing only) in 2010 to that in 2011?
Ensure brevity in your answer.  0.96. What is the ratio of the Value added (constant 2005 US$) of Bhutan in 2010 to that in 2011?
Offer a terse response. 0.98. What is the ratio of the Value added (constant 2005 US$) of Liberia in 2010 to that in 2011?
Ensure brevity in your answer.  0.96. What is the difference between the highest and the second highest Value added (constant 2005 US$) in East Asia (developing only)?
Give a very brief answer. 1.92e+1. What is the difference between the highest and the second highest Value added (constant 2005 US$) of Bhutan?
Your answer should be very brief. 4.76e+06. What is the difference between the highest and the second highest Value added (constant 2005 US$) of Gabon?
Provide a short and direct response. 2.83e+07. What is the difference between the highest and the second highest Value added (constant 2005 US$) of Liberia?
Provide a short and direct response. 1.48e+07. What is the difference between the highest and the lowest Value added (constant 2005 US$) of East Asia (developing only)?
Provide a short and direct response. 8.24e+1. What is the difference between the highest and the lowest Value added (constant 2005 US$) of Bhutan?
Your answer should be very brief. 1.43e+07. What is the difference between the highest and the lowest Value added (constant 2005 US$) of Gabon?
Keep it short and to the point. 9.51e+07. What is the difference between the highest and the lowest Value added (constant 2005 US$) in Liberia?
Make the answer very short. 1.01e+08. 